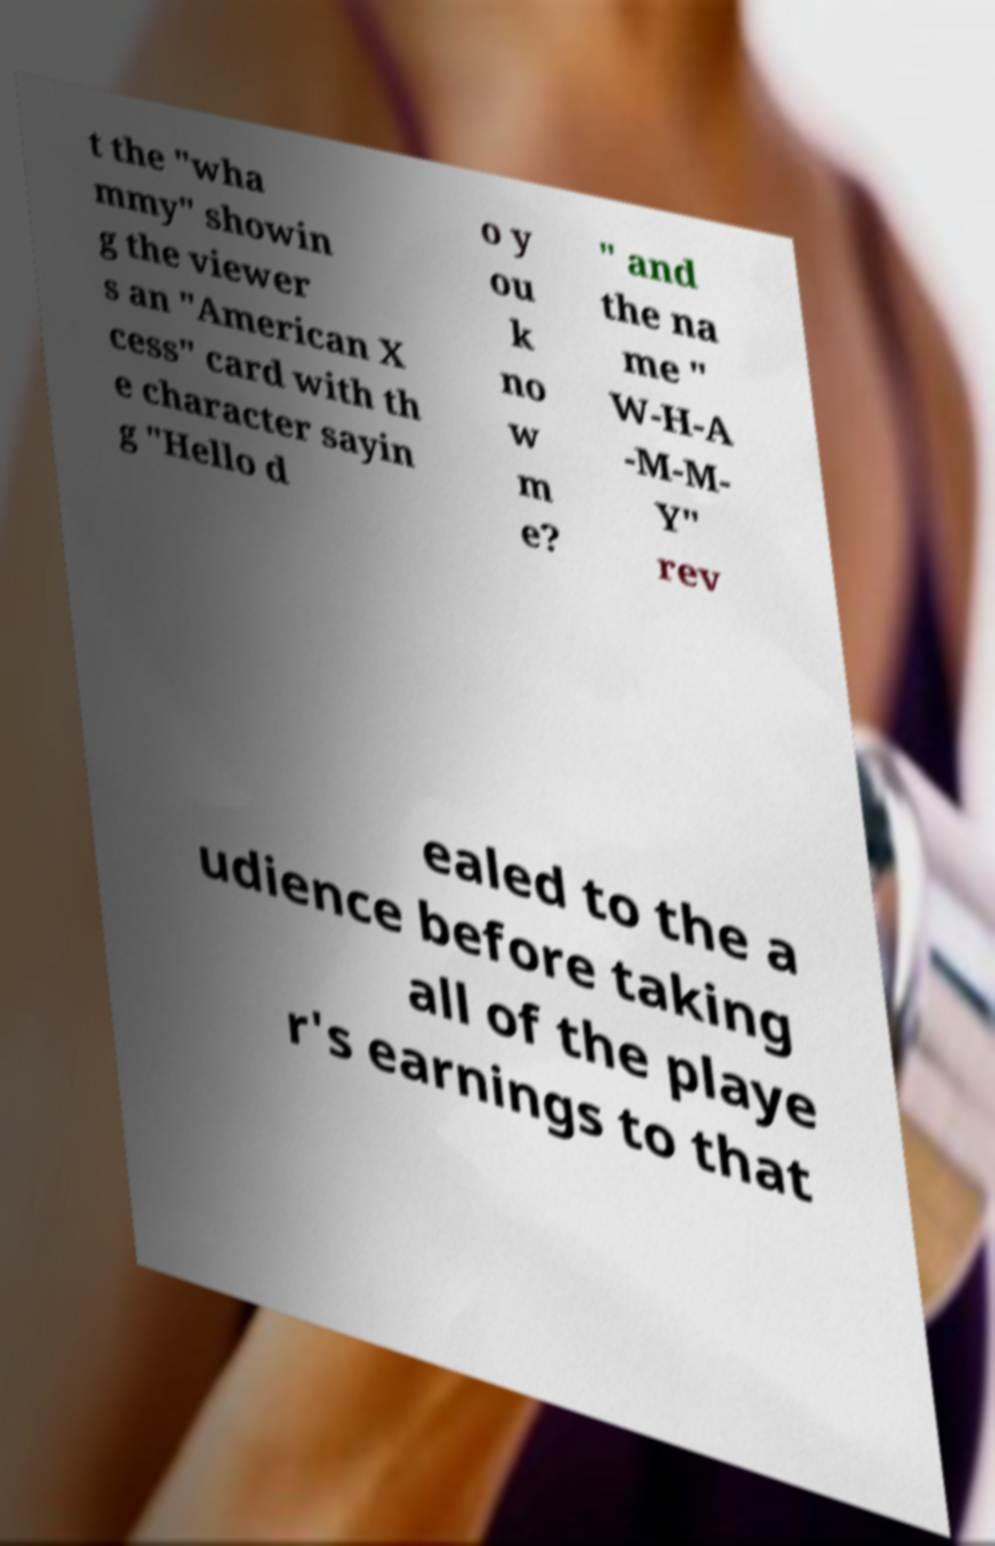For documentation purposes, I need the text within this image transcribed. Could you provide that? t the "wha mmy" showin g the viewer s an "American X cess" card with th e character sayin g "Hello d o y ou k no w m e? " and the na me " W-H-A -M-M- Y" rev ealed to the a udience before taking all of the playe r's earnings to that 